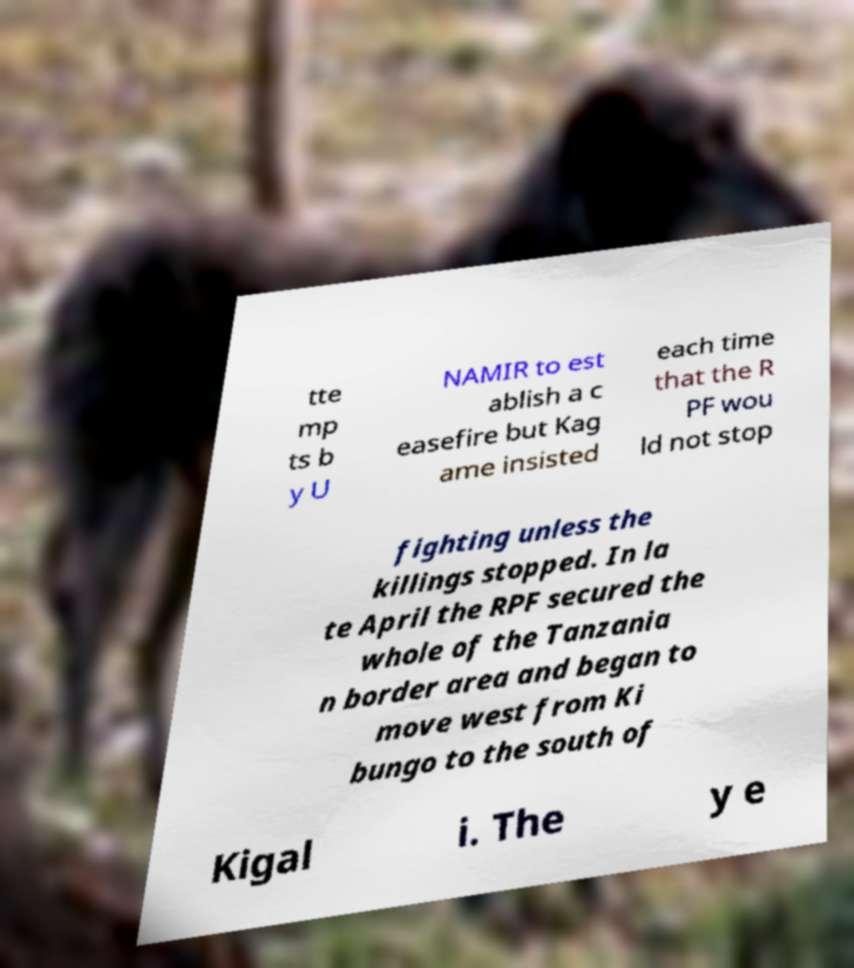Please identify and transcribe the text found in this image. tte mp ts b y U NAMIR to est ablish a c easefire but Kag ame insisted each time that the R PF wou ld not stop fighting unless the killings stopped. In la te April the RPF secured the whole of the Tanzania n border area and began to move west from Ki bungo to the south of Kigal i. The y e 